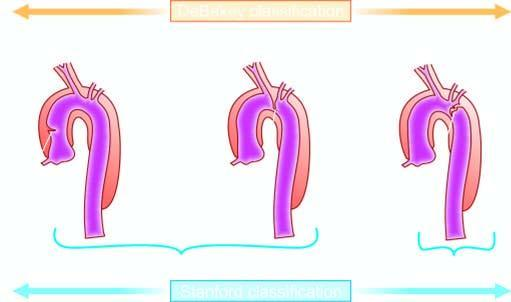what is stanford type b limited to?
Answer the question using a single word or phrase. Descending aorta 